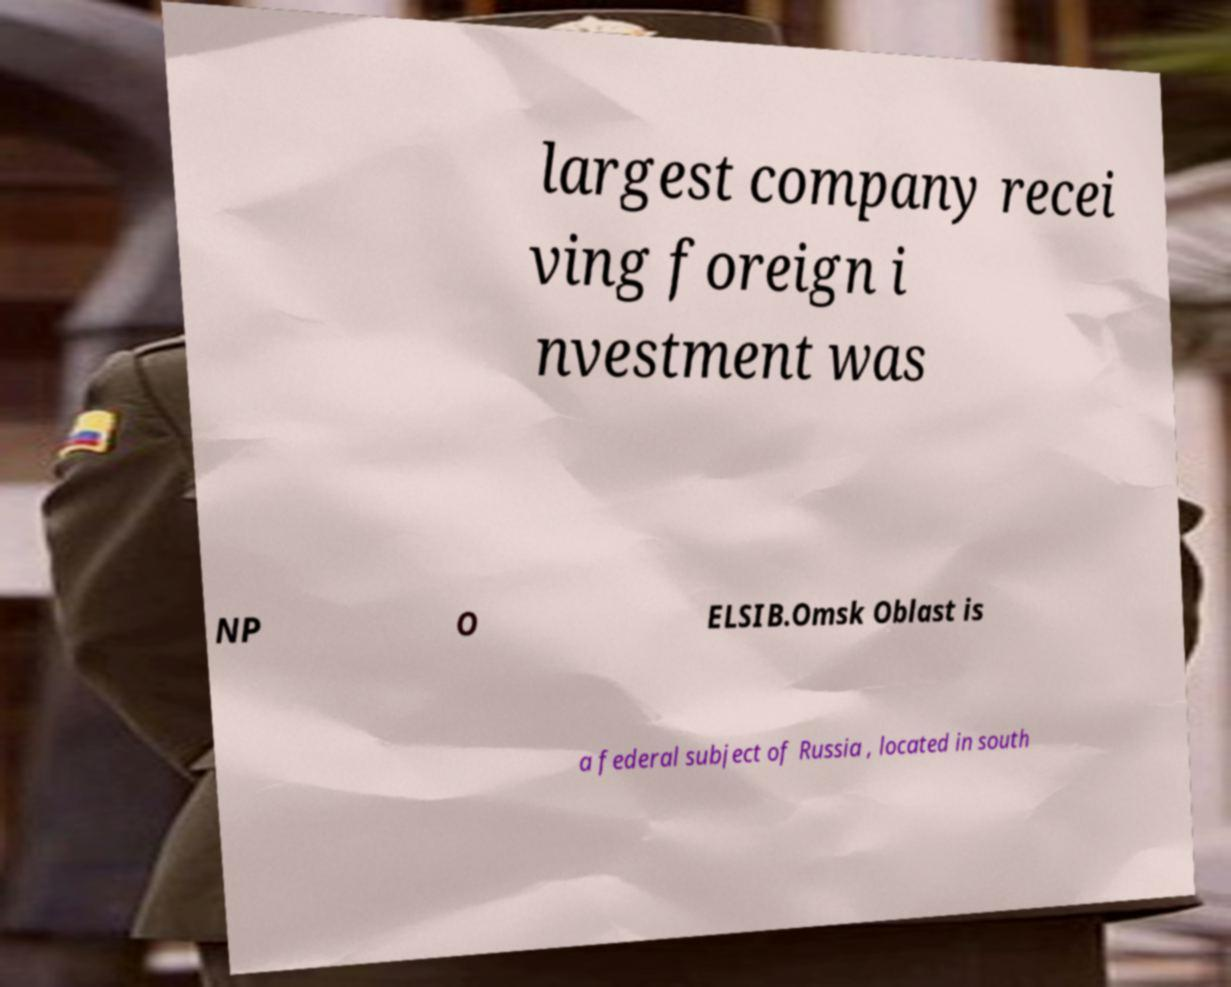Please read and relay the text visible in this image. What does it say? largest company recei ving foreign i nvestment was NP O ELSIB.Omsk Oblast is a federal subject of Russia , located in south 